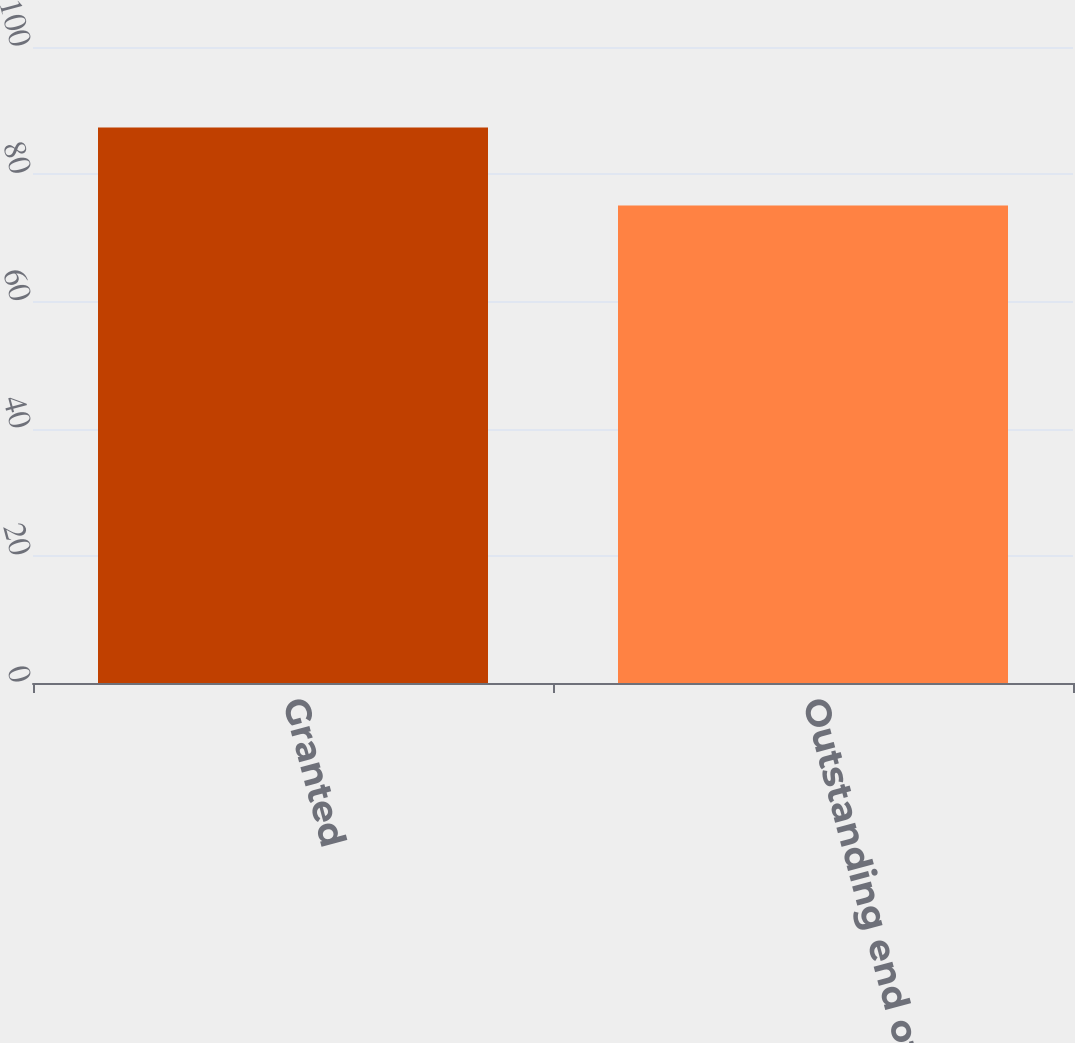Convert chart to OTSL. <chart><loc_0><loc_0><loc_500><loc_500><bar_chart><fcel>Granted<fcel>Outstanding end of year<nl><fcel>87.36<fcel>75.06<nl></chart> 